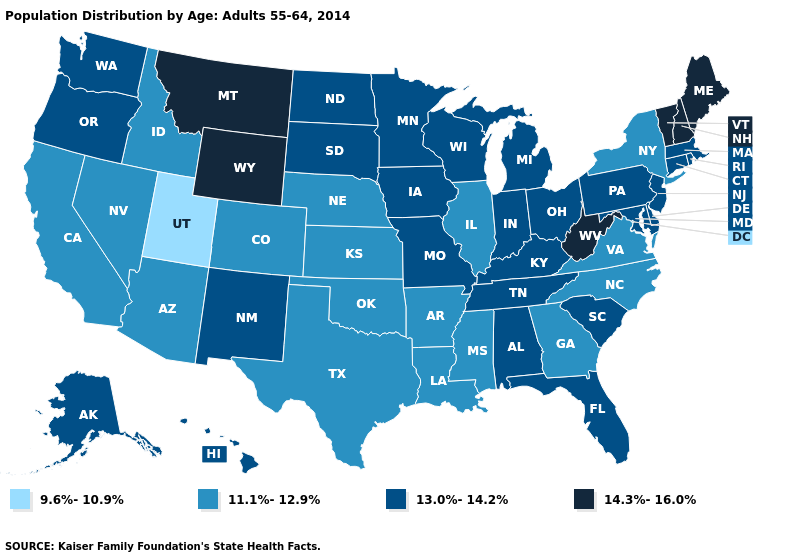Does Mississippi have a higher value than Maine?
Write a very short answer. No. Name the states that have a value in the range 13.0%-14.2%?
Concise answer only. Alabama, Alaska, Connecticut, Delaware, Florida, Hawaii, Indiana, Iowa, Kentucky, Maryland, Massachusetts, Michigan, Minnesota, Missouri, New Jersey, New Mexico, North Dakota, Ohio, Oregon, Pennsylvania, Rhode Island, South Carolina, South Dakota, Tennessee, Washington, Wisconsin. Which states hav the highest value in the South?
Be succinct. West Virginia. Does Nevada have a lower value than Arkansas?
Concise answer only. No. Which states hav the highest value in the West?
Concise answer only. Montana, Wyoming. Name the states that have a value in the range 13.0%-14.2%?
Write a very short answer. Alabama, Alaska, Connecticut, Delaware, Florida, Hawaii, Indiana, Iowa, Kentucky, Maryland, Massachusetts, Michigan, Minnesota, Missouri, New Jersey, New Mexico, North Dakota, Ohio, Oregon, Pennsylvania, Rhode Island, South Carolina, South Dakota, Tennessee, Washington, Wisconsin. What is the value of Minnesota?
Be succinct. 13.0%-14.2%. Does California have a lower value than Idaho?
Keep it brief. No. What is the value of Tennessee?
Write a very short answer. 13.0%-14.2%. Is the legend a continuous bar?
Concise answer only. No. Does Florida have a higher value than Michigan?
Short answer required. No. What is the value of Oregon?
Give a very brief answer. 13.0%-14.2%. Among the states that border Wisconsin , which have the lowest value?
Be succinct. Illinois. Which states have the highest value in the USA?
Answer briefly. Maine, Montana, New Hampshire, Vermont, West Virginia, Wyoming. What is the value of Illinois?
Short answer required. 11.1%-12.9%. 